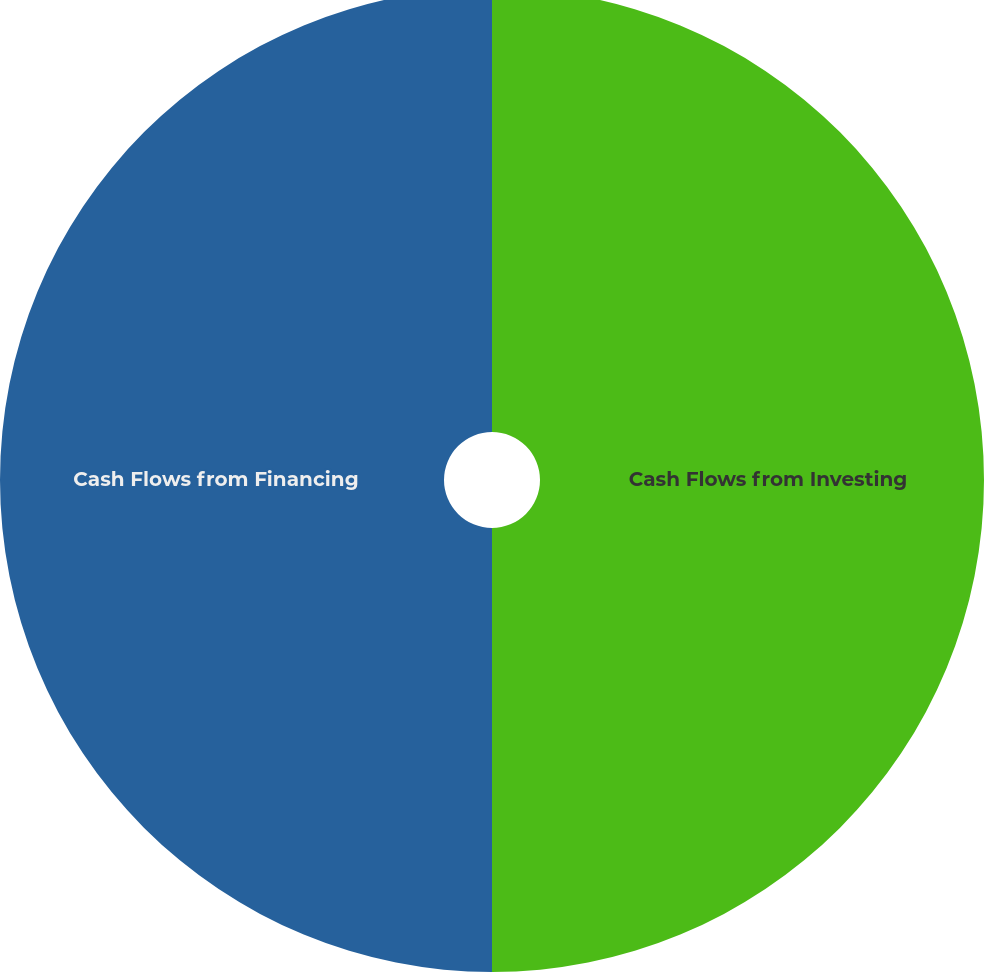<chart> <loc_0><loc_0><loc_500><loc_500><pie_chart><fcel>Cash Flows from Investing<fcel>Cash Flows from Financing<nl><fcel>50.0%<fcel>50.0%<nl></chart> 